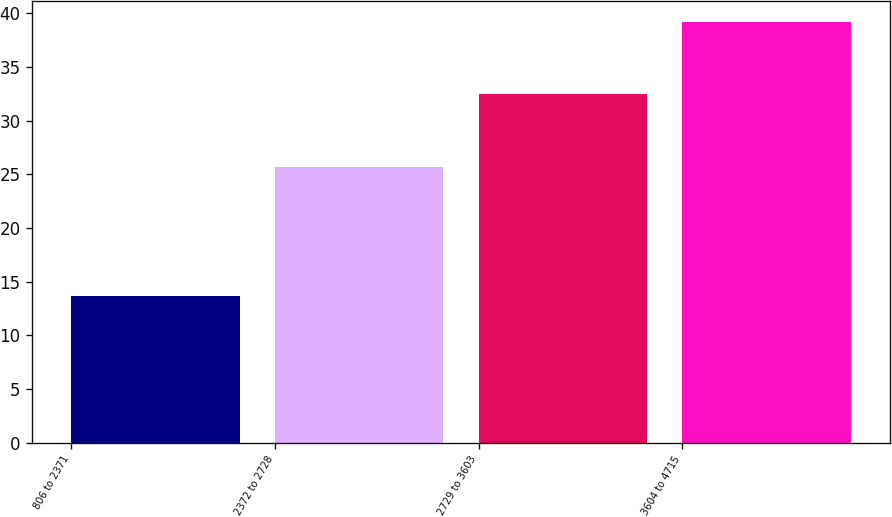Convert chart. <chart><loc_0><loc_0><loc_500><loc_500><bar_chart><fcel>806 to 2371<fcel>2372 to 2728<fcel>2729 to 3603<fcel>3604 to 4715<nl><fcel>13.62<fcel>25.7<fcel>32.48<fcel>39.24<nl></chart> 